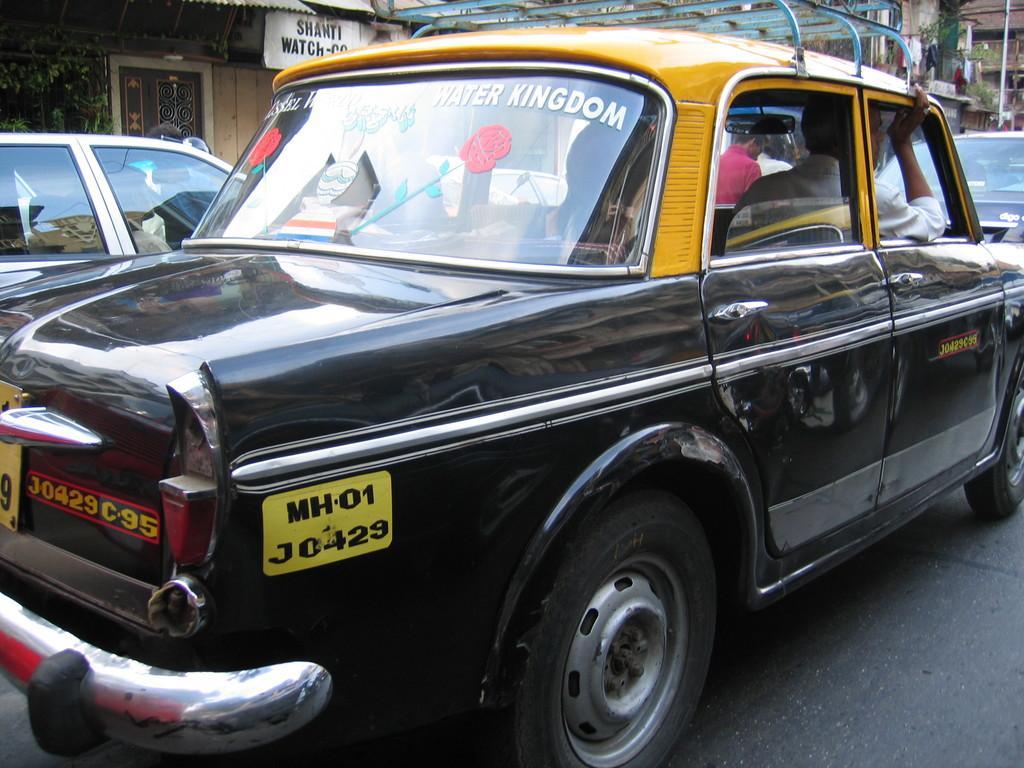How would you summarize this image in a sentence or two? In this image we can see cars on the road and there are people sitting in the cars. In the background there are sheds. 